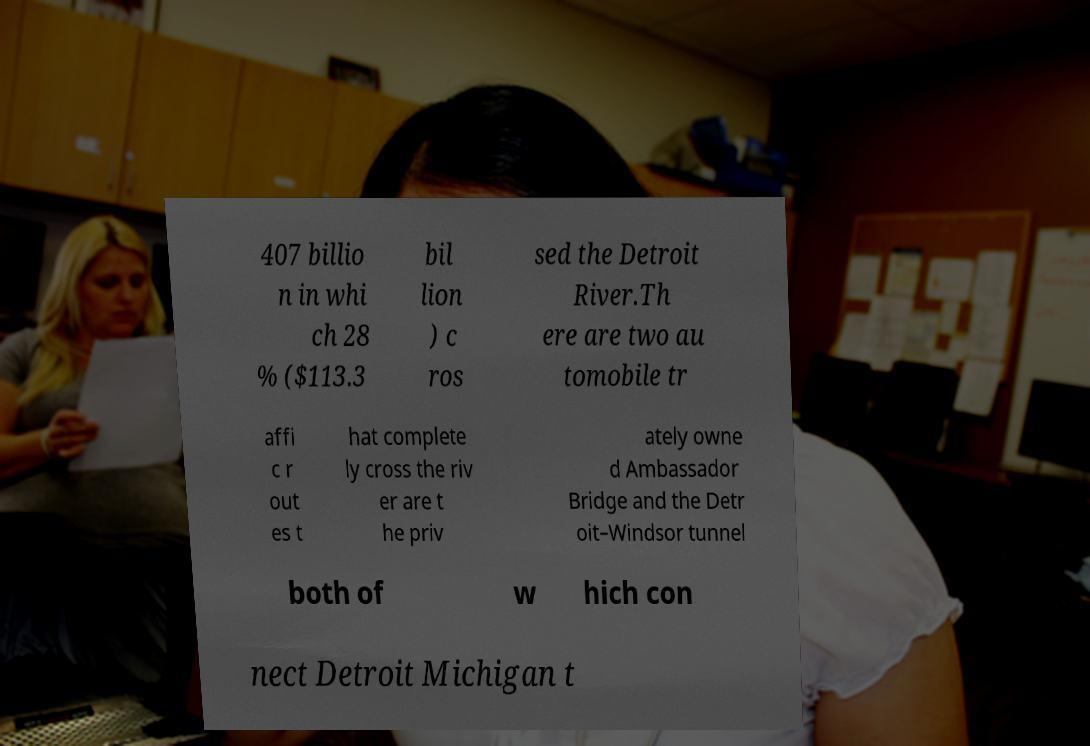For documentation purposes, I need the text within this image transcribed. Could you provide that? 407 billio n in whi ch 28 % ($113.3 bil lion ) c ros sed the Detroit River.Th ere are two au tomobile tr affi c r out es t hat complete ly cross the riv er are t he priv ately owne d Ambassador Bridge and the Detr oit–Windsor tunnel both of w hich con nect Detroit Michigan t 